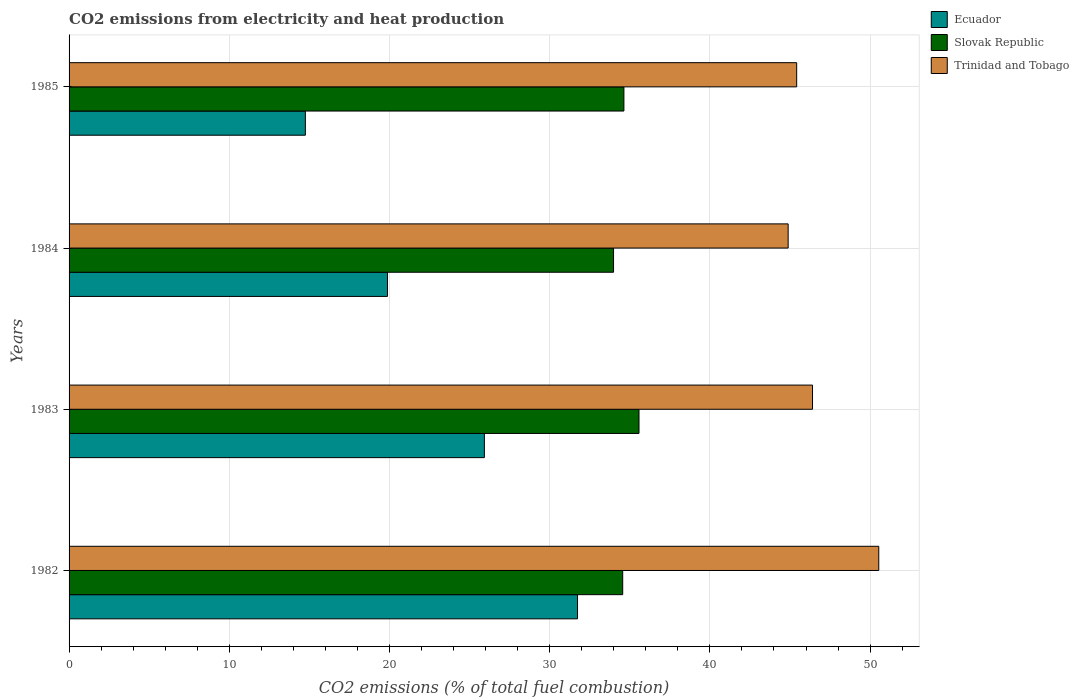How many different coloured bars are there?
Keep it short and to the point. 3. How many groups of bars are there?
Offer a very short reply. 4. Are the number of bars per tick equal to the number of legend labels?
Keep it short and to the point. Yes. Are the number of bars on each tick of the Y-axis equal?
Give a very brief answer. Yes. How many bars are there on the 3rd tick from the top?
Offer a very short reply. 3. How many bars are there on the 4th tick from the bottom?
Give a very brief answer. 3. What is the label of the 1st group of bars from the top?
Your answer should be compact. 1985. In how many cases, is the number of bars for a given year not equal to the number of legend labels?
Offer a terse response. 0. What is the amount of CO2 emitted in Ecuador in 1985?
Your response must be concise. 14.75. Across all years, what is the maximum amount of CO2 emitted in Slovak Republic?
Make the answer very short. 35.57. Across all years, what is the minimum amount of CO2 emitted in Ecuador?
Provide a succinct answer. 14.75. In which year was the amount of CO2 emitted in Ecuador minimum?
Offer a very short reply. 1985. What is the total amount of CO2 emitted in Slovak Republic in the graph?
Your answer should be very brief. 138.75. What is the difference between the amount of CO2 emitted in Slovak Republic in 1983 and that in 1984?
Give a very brief answer. 1.59. What is the difference between the amount of CO2 emitted in Ecuador in 1985 and the amount of CO2 emitted in Slovak Republic in 1982?
Provide a short and direct response. -19.81. What is the average amount of CO2 emitted in Ecuador per year?
Give a very brief answer. 23.07. In the year 1983, what is the difference between the amount of CO2 emitted in Slovak Republic and amount of CO2 emitted in Ecuador?
Your response must be concise. 9.65. What is the ratio of the amount of CO2 emitted in Trinidad and Tobago in 1982 to that in 1984?
Ensure brevity in your answer.  1.13. Is the amount of CO2 emitted in Trinidad and Tobago in 1984 less than that in 1985?
Offer a very short reply. Yes. What is the difference between the highest and the second highest amount of CO2 emitted in Ecuador?
Offer a terse response. 5.82. What is the difference between the highest and the lowest amount of CO2 emitted in Trinidad and Tobago?
Make the answer very short. 5.66. In how many years, is the amount of CO2 emitted in Trinidad and Tobago greater than the average amount of CO2 emitted in Trinidad and Tobago taken over all years?
Provide a short and direct response. 1. What does the 2nd bar from the top in 1984 represents?
Provide a succinct answer. Slovak Republic. What does the 1st bar from the bottom in 1982 represents?
Provide a short and direct response. Ecuador. What is the difference between two consecutive major ticks on the X-axis?
Offer a very short reply. 10. Are the values on the major ticks of X-axis written in scientific E-notation?
Give a very brief answer. No. Does the graph contain any zero values?
Your answer should be very brief. No. Does the graph contain grids?
Give a very brief answer. Yes. How many legend labels are there?
Your answer should be very brief. 3. What is the title of the graph?
Offer a terse response. CO2 emissions from electricity and heat production. What is the label or title of the X-axis?
Keep it short and to the point. CO2 emissions (% of total fuel combustion). What is the CO2 emissions (% of total fuel combustion) of Ecuador in 1982?
Offer a terse response. 31.74. What is the CO2 emissions (% of total fuel combustion) of Slovak Republic in 1982?
Your answer should be compact. 34.56. What is the CO2 emissions (% of total fuel combustion) in Trinidad and Tobago in 1982?
Provide a short and direct response. 50.54. What is the CO2 emissions (% of total fuel combustion) in Ecuador in 1983?
Your answer should be compact. 25.92. What is the CO2 emissions (% of total fuel combustion) of Slovak Republic in 1983?
Keep it short and to the point. 35.57. What is the CO2 emissions (% of total fuel combustion) of Trinidad and Tobago in 1983?
Ensure brevity in your answer.  46.41. What is the CO2 emissions (% of total fuel combustion) of Ecuador in 1984?
Provide a succinct answer. 19.88. What is the CO2 emissions (% of total fuel combustion) in Slovak Republic in 1984?
Your answer should be compact. 33.99. What is the CO2 emissions (% of total fuel combustion) of Trinidad and Tobago in 1984?
Give a very brief answer. 44.89. What is the CO2 emissions (% of total fuel combustion) in Ecuador in 1985?
Make the answer very short. 14.75. What is the CO2 emissions (% of total fuel combustion) of Slovak Republic in 1985?
Provide a succinct answer. 34.63. What is the CO2 emissions (% of total fuel combustion) of Trinidad and Tobago in 1985?
Offer a very short reply. 45.42. Across all years, what is the maximum CO2 emissions (% of total fuel combustion) of Ecuador?
Provide a succinct answer. 31.74. Across all years, what is the maximum CO2 emissions (% of total fuel combustion) of Slovak Republic?
Make the answer very short. 35.57. Across all years, what is the maximum CO2 emissions (% of total fuel combustion) of Trinidad and Tobago?
Your answer should be very brief. 50.54. Across all years, what is the minimum CO2 emissions (% of total fuel combustion) in Ecuador?
Your response must be concise. 14.75. Across all years, what is the minimum CO2 emissions (% of total fuel combustion) in Slovak Republic?
Your answer should be compact. 33.99. Across all years, what is the minimum CO2 emissions (% of total fuel combustion) in Trinidad and Tobago?
Provide a succinct answer. 44.89. What is the total CO2 emissions (% of total fuel combustion) in Ecuador in the graph?
Your answer should be very brief. 92.28. What is the total CO2 emissions (% of total fuel combustion) of Slovak Republic in the graph?
Offer a very short reply. 138.75. What is the total CO2 emissions (% of total fuel combustion) in Trinidad and Tobago in the graph?
Make the answer very short. 187.25. What is the difference between the CO2 emissions (% of total fuel combustion) of Ecuador in 1982 and that in 1983?
Keep it short and to the point. 5.82. What is the difference between the CO2 emissions (% of total fuel combustion) of Slovak Republic in 1982 and that in 1983?
Provide a short and direct response. -1.02. What is the difference between the CO2 emissions (% of total fuel combustion) in Trinidad and Tobago in 1982 and that in 1983?
Give a very brief answer. 4.14. What is the difference between the CO2 emissions (% of total fuel combustion) in Ecuador in 1982 and that in 1984?
Keep it short and to the point. 11.86. What is the difference between the CO2 emissions (% of total fuel combustion) in Slovak Republic in 1982 and that in 1984?
Give a very brief answer. 0.57. What is the difference between the CO2 emissions (% of total fuel combustion) of Trinidad and Tobago in 1982 and that in 1984?
Offer a very short reply. 5.66. What is the difference between the CO2 emissions (% of total fuel combustion) in Ecuador in 1982 and that in 1985?
Offer a very short reply. 16.99. What is the difference between the CO2 emissions (% of total fuel combustion) in Slovak Republic in 1982 and that in 1985?
Give a very brief answer. -0.08. What is the difference between the CO2 emissions (% of total fuel combustion) of Trinidad and Tobago in 1982 and that in 1985?
Your answer should be compact. 5.12. What is the difference between the CO2 emissions (% of total fuel combustion) in Ecuador in 1983 and that in 1984?
Ensure brevity in your answer.  6.05. What is the difference between the CO2 emissions (% of total fuel combustion) in Slovak Republic in 1983 and that in 1984?
Give a very brief answer. 1.59. What is the difference between the CO2 emissions (% of total fuel combustion) in Trinidad and Tobago in 1983 and that in 1984?
Your answer should be compact. 1.52. What is the difference between the CO2 emissions (% of total fuel combustion) of Ecuador in 1983 and that in 1985?
Ensure brevity in your answer.  11.17. What is the difference between the CO2 emissions (% of total fuel combustion) of Slovak Republic in 1983 and that in 1985?
Offer a terse response. 0.94. What is the difference between the CO2 emissions (% of total fuel combustion) in Trinidad and Tobago in 1983 and that in 1985?
Keep it short and to the point. 0.99. What is the difference between the CO2 emissions (% of total fuel combustion) in Ecuador in 1984 and that in 1985?
Ensure brevity in your answer.  5.13. What is the difference between the CO2 emissions (% of total fuel combustion) in Slovak Republic in 1984 and that in 1985?
Your answer should be compact. -0.65. What is the difference between the CO2 emissions (% of total fuel combustion) in Trinidad and Tobago in 1984 and that in 1985?
Your answer should be very brief. -0.53. What is the difference between the CO2 emissions (% of total fuel combustion) in Ecuador in 1982 and the CO2 emissions (% of total fuel combustion) in Slovak Republic in 1983?
Make the answer very short. -3.84. What is the difference between the CO2 emissions (% of total fuel combustion) in Ecuador in 1982 and the CO2 emissions (% of total fuel combustion) in Trinidad and Tobago in 1983?
Make the answer very short. -14.67. What is the difference between the CO2 emissions (% of total fuel combustion) in Slovak Republic in 1982 and the CO2 emissions (% of total fuel combustion) in Trinidad and Tobago in 1983?
Your response must be concise. -11.85. What is the difference between the CO2 emissions (% of total fuel combustion) of Ecuador in 1982 and the CO2 emissions (% of total fuel combustion) of Slovak Republic in 1984?
Give a very brief answer. -2.25. What is the difference between the CO2 emissions (% of total fuel combustion) of Ecuador in 1982 and the CO2 emissions (% of total fuel combustion) of Trinidad and Tobago in 1984?
Ensure brevity in your answer.  -13.15. What is the difference between the CO2 emissions (% of total fuel combustion) in Slovak Republic in 1982 and the CO2 emissions (% of total fuel combustion) in Trinidad and Tobago in 1984?
Give a very brief answer. -10.33. What is the difference between the CO2 emissions (% of total fuel combustion) of Ecuador in 1982 and the CO2 emissions (% of total fuel combustion) of Slovak Republic in 1985?
Give a very brief answer. -2.89. What is the difference between the CO2 emissions (% of total fuel combustion) in Ecuador in 1982 and the CO2 emissions (% of total fuel combustion) in Trinidad and Tobago in 1985?
Keep it short and to the point. -13.68. What is the difference between the CO2 emissions (% of total fuel combustion) of Slovak Republic in 1982 and the CO2 emissions (% of total fuel combustion) of Trinidad and Tobago in 1985?
Keep it short and to the point. -10.86. What is the difference between the CO2 emissions (% of total fuel combustion) in Ecuador in 1983 and the CO2 emissions (% of total fuel combustion) in Slovak Republic in 1984?
Keep it short and to the point. -8.06. What is the difference between the CO2 emissions (% of total fuel combustion) in Ecuador in 1983 and the CO2 emissions (% of total fuel combustion) in Trinidad and Tobago in 1984?
Your response must be concise. -18.96. What is the difference between the CO2 emissions (% of total fuel combustion) in Slovak Republic in 1983 and the CO2 emissions (% of total fuel combustion) in Trinidad and Tobago in 1984?
Give a very brief answer. -9.31. What is the difference between the CO2 emissions (% of total fuel combustion) in Ecuador in 1983 and the CO2 emissions (% of total fuel combustion) in Slovak Republic in 1985?
Provide a succinct answer. -8.71. What is the difference between the CO2 emissions (% of total fuel combustion) in Ecuador in 1983 and the CO2 emissions (% of total fuel combustion) in Trinidad and Tobago in 1985?
Keep it short and to the point. -19.49. What is the difference between the CO2 emissions (% of total fuel combustion) of Slovak Republic in 1983 and the CO2 emissions (% of total fuel combustion) of Trinidad and Tobago in 1985?
Your response must be concise. -9.84. What is the difference between the CO2 emissions (% of total fuel combustion) of Ecuador in 1984 and the CO2 emissions (% of total fuel combustion) of Slovak Republic in 1985?
Make the answer very short. -14.76. What is the difference between the CO2 emissions (% of total fuel combustion) of Ecuador in 1984 and the CO2 emissions (% of total fuel combustion) of Trinidad and Tobago in 1985?
Your response must be concise. -25.54. What is the difference between the CO2 emissions (% of total fuel combustion) in Slovak Republic in 1984 and the CO2 emissions (% of total fuel combustion) in Trinidad and Tobago in 1985?
Provide a succinct answer. -11.43. What is the average CO2 emissions (% of total fuel combustion) in Ecuador per year?
Offer a terse response. 23.07. What is the average CO2 emissions (% of total fuel combustion) in Slovak Republic per year?
Your response must be concise. 34.69. What is the average CO2 emissions (% of total fuel combustion) of Trinidad and Tobago per year?
Provide a succinct answer. 46.81. In the year 1982, what is the difference between the CO2 emissions (% of total fuel combustion) of Ecuador and CO2 emissions (% of total fuel combustion) of Slovak Republic?
Ensure brevity in your answer.  -2.82. In the year 1982, what is the difference between the CO2 emissions (% of total fuel combustion) in Ecuador and CO2 emissions (% of total fuel combustion) in Trinidad and Tobago?
Your answer should be compact. -18.8. In the year 1982, what is the difference between the CO2 emissions (% of total fuel combustion) in Slovak Republic and CO2 emissions (% of total fuel combustion) in Trinidad and Tobago?
Provide a succinct answer. -15.98. In the year 1983, what is the difference between the CO2 emissions (% of total fuel combustion) in Ecuador and CO2 emissions (% of total fuel combustion) in Slovak Republic?
Offer a terse response. -9.65. In the year 1983, what is the difference between the CO2 emissions (% of total fuel combustion) in Ecuador and CO2 emissions (% of total fuel combustion) in Trinidad and Tobago?
Give a very brief answer. -20.48. In the year 1983, what is the difference between the CO2 emissions (% of total fuel combustion) of Slovak Republic and CO2 emissions (% of total fuel combustion) of Trinidad and Tobago?
Your answer should be compact. -10.83. In the year 1984, what is the difference between the CO2 emissions (% of total fuel combustion) in Ecuador and CO2 emissions (% of total fuel combustion) in Slovak Republic?
Offer a very short reply. -14.11. In the year 1984, what is the difference between the CO2 emissions (% of total fuel combustion) in Ecuador and CO2 emissions (% of total fuel combustion) in Trinidad and Tobago?
Provide a short and direct response. -25.01. In the year 1984, what is the difference between the CO2 emissions (% of total fuel combustion) of Slovak Republic and CO2 emissions (% of total fuel combustion) of Trinidad and Tobago?
Offer a terse response. -10.9. In the year 1985, what is the difference between the CO2 emissions (% of total fuel combustion) of Ecuador and CO2 emissions (% of total fuel combustion) of Slovak Republic?
Keep it short and to the point. -19.88. In the year 1985, what is the difference between the CO2 emissions (% of total fuel combustion) in Ecuador and CO2 emissions (% of total fuel combustion) in Trinidad and Tobago?
Ensure brevity in your answer.  -30.67. In the year 1985, what is the difference between the CO2 emissions (% of total fuel combustion) of Slovak Republic and CO2 emissions (% of total fuel combustion) of Trinidad and Tobago?
Provide a succinct answer. -10.78. What is the ratio of the CO2 emissions (% of total fuel combustion) in Ecuador in 1982 to that in 1983?
Offer a very short reply. 1.22. What is the ratio of the CO2 emissions (% of total fuel combustion) of Slovak Republic in 1982 to that in 1983?
Ensure brevity in your answer.  0.97. What is the ratio of the CO2 emissions (% of total fuel combustion) of Trinidad and Tobago in 1982 to that in 1983?
Ensure brevity in your answer.  1.09. What is the ratio of the CO2 emissions (% of total fuel combustion) of Ecuador in 1982 to that in 1984?
Provide a short and direct response. 1.6. What is the ratio of the CO2 emissions (% of total fuel combustion) in Slovak Republic in 1982 to that in 1984?
Provide a succinct answer. 1.02. What is the ratio of the CO2 emissions (% of total fuel combustion) of Trinidad and Tobago in 1982 to that in 1984?
Provide a short and direct response. 1.13. What is the ratio of the CO2 emissions (% of total fuel combustion) of Ecuador in 1982 to that in 1985?
Make the answer very short. 2.15. What is the ratio of the CO2 emissions (% of total fuel combustion) of Trinidad and Tobago in 1982 to that in 1985?
Make the answer very short. 1.11. What is the ratio of the CO2 emissions (% of total fuel combustion) in Ecuador in 1983 to that in 1984?
Provide a succinct answer. 1.3. What is the ratio of the CO2 emissions (% of total fuel combustion) in Slovak Republic in 1983 to that in 1984?
Ensure brevity in your answer.  1.05. What is the ratio of the CO2 emissions (% of total fuel combustion) of Trinidad and Tobago in 1983 to that in 1984?
Provide a succinct answer. 1.03. What is the ratio of the CO2 emissions (% of total fuel combustion) in Ecuador in 1983 to that in 1985?
Your answer should be compact. 1.76. What is the ratio of the CO2 emissions (% of total fuel combustion) in Slovak Republic in 1983 to that in 1985?
Keep it short and to the point. 1.03. What is the ratio of the CO2 emissions (% of total fuel combustion) of Trinidad and Tobago in 1983 to that in 1985?
Ensure brevity in your answer.  1.02. What is the ratio of the CO2 emissions (% of total fuel combustion) in Ecuador in 1984 to that in 1985?
Your response must be concise. 1.35. What is the ratio of the CO2 emissions (% of total fuel combustion) in Slovak Republic in 1984 to that in 1985?
Provide a succinct answer. 0.98. What is the ratio of the CO2 emissions (% of total fuel combustion) in Trinidad and Tobago in 1984 to that in 1985?
Offer a very short reply. 0.99. What is the difference between the highest and the second highest CO2 emissions (% of total fuel combustion) of Ecuador?
Make the answer very short. 5.82. What is the difference between the highest and the second highest CO2 emissions (% of total fuel combustion) in Slovak Republic?
Provide a succinct answer. 0.94. What is the difference between the highest and the second highest CO2 emissions (% of total fuel combustion) in Trinidad and Tobago?
Keep it short and to the point. 4.14. What is the difference between the highest and the lowest CO2 emissions (% of total fuel combustion) in Ecuador?
Keep it short and to the point. 16.99. What is the difference between the highest and the lowest CO2 emissions (% of total fuel combustion) of Slovak Republic?
Provide a short and direct response. 1.59. What is the difference between the highest and the lowest CO2 emissions (% of total fuel combustion) in Trinidad and Tobago?
Give a very brief answer. 5.66. 